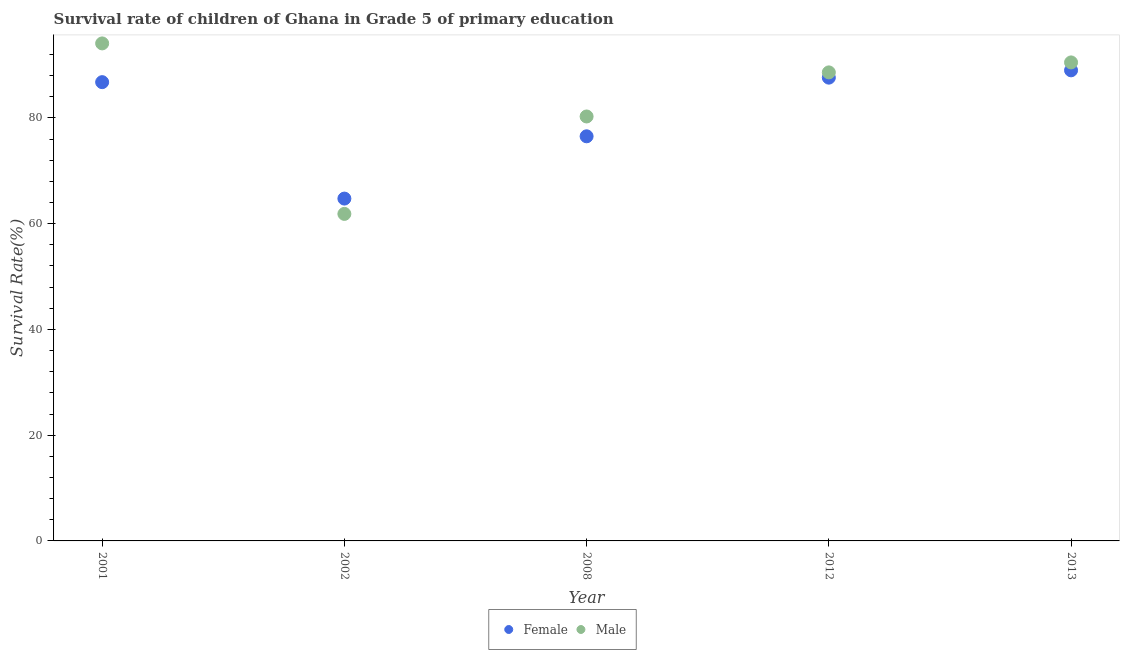How many different coloured dotlines are there?
Your answer should be compact. 2. Is the number of dotlines equal to the number of legend labels?
Provide a succinct answer. Yes. What is the survival rate of male students in primary education in 2002?
Provide a succinct answer. 61.85. Across all years, what is the maximum survival rate of male students in primary education?
Your response must be concise. 94.09. Across all years, what is the minimum survival rate of male students in primary education?
Offer a very short reply. 61.85. In which year was the survival rate of male students in primary education maximum?
Provide a succinct answer. 2001. In which year was the survival rate of female students in primary education minimum?
Ensure brevity in your answer.  2002. What is the total survival rate of male students in primary education in the graph?
Your answer should be very brief. 415.32. What is the difference between the survival rate of male students in primary education in 2012 and that in 2013?
Ensure brevity in your answer.  -1.88. What is the difference between the survival rate of male students in primary education in 2002 and the survival rate of female students in primary education in 2008?
Provide a succinct answer. -14.67. What is the average survival rate of female students in primary education per year?
Ensure brevity in your answer.  80.93. In the year 2002, what is the difference between the survival rate of female students in primary education and survival rate of male students in primary education?
Keep it short and to the point. 2.9. What is the ratio of the survival rate of female students in primary education in 2002 to that in 2013?
Offer a terse response. 0.73. What is the difference between the highest and the second highest survival rate of male students in primary education?
Make the answer very short. 3.6. What is the difference between the highest and the lowest survival rate of male students in primary education?
Offer a very short reply. 32.24. In how many years, is the survival rate of male students in primary education greater than the average survival rate of male students in primary education taken over all years?
Your answer should be very brief. 3. How many dotlines are there?
Give a very brief answer. 2. What is the difference between two consecutive major ticks on the Y-axis?
Offer a very short reply. 20. Does the graph contain any zero values?
Keep it short and to the point. No. Does the graph contain grids?
Give a very brief answer. No. How many legend labels are there?
Make the answer very short. 2. What is the title of the graph?
Provide a succinct answer. Survival rate of children of Ghana in Grade 5 of primary education. Does "From World Bank" appear as one of the legend labels in the graph?
Offer a terse response. No. What is the label or title of the X-axis?
Provide a short and direct response. Year. What is the label or title of the Y-axis?
Keep it short and to the point. Survival Rate(%). What is the Survival Rate(%) of Female in 2001?
Make the answer very short. 86.76. What is the Survival Rate(%) in Male in 2001?
Your answer should be very brief. 94.09. What is the Survival Rate(%) of Female in 2002?
Offer a very short reply. 64.74. What is the Survival Rate(%) of Male in 2002?
Ensure brevity in your answer.  61.85. What is the Survival Rate(%) of Female in 2008?
Ensure brevity in your answer.  76.52. What is the Survival Rate(%) of Male in 2008?
Offer a very short reply. 80.27. What is the Survival Rate(%) in Female in 2012?
Give a very brief answer. 87.61. What is the Survival Rate(%) in Male in 2012?
Ensure brevity in your answer.  88.61. What is the Survival Rate(%) of Female in 2013?
Make the answer very short. 89. What is the Survival Rate(%) in Male in 2013?
Ensure brevity in your answer.  90.49. Across all years, what is the maximum Survival Rate(%) of Female?
Give a very brief answer. 89. Across all years, what is the maximum Survival Rate(%) in Male?
Provide a short and direct response. 94.09. Across all years, what is the minimum Survival Rate(%) of Female?
Ensure brevity in your answer.  64.74. Across all years, what is the minimum Survival Rate(%) of Male?
Your answer should be very brief. 61.85. What is the total Survival Rate(%) of Female in the graph?
Give a very brief answer. 404.64. What is the total Survival Rate(%) in Male in the graph?
Your answer should be very brief. 415.32. What is the difference between the Survival Rate(%) in Female in 2001 and that in 2002?
Offer a terse response. 22.02. What is the difference between the Survival Rate(%) in Male in 2001 and that in 2002?
Your answer should be compact. 32.24. What is the difference between the Survival Rate(%) of Female in 2001 and that in 2008?
Your answer should be very brief. 10.24. What is the difference between the Survival Rate(%) in Male in 2001 and that in 2008?
Provide a short and direct response. 13.82. What is the difference between the Survival Rate(%) in Female in 2001 and that in 2012?
Your answer should be very brief. -0.85. What is the difference between the Survival Rate(%) in Male in 2001 and that in 2012?
Your answer should be compact. 5.48. What is the difference between the Survival Rate(%) of Female in 2001 and that in 2013?
Your answer should be very brief. -2.23. What is the difference between the Survival Rate(%) of Male in 2001 and that in 2013?
Your response must be concise. 3.6. What is the difference between the Survival Rate(%) of Female in 2002 and that in 2008?
Provide a succinct answer. -11.78. What is the difference between the Survival Rate(%) of Male in 2002 and that in 2008?
Give a very brief answer. -18.42. What is the difference between the Survival Rate(%) of Female in 2002 and that in 2012?
Give a very brief answer. -22.87. What is the difference between the Survival Rate(%) in Male in 2002 and that in 2012?
Offer a very short reply. -26.76. What is the difference between the Survival Rate(%) of Female in 2002 and that in 2013?
Your answer should be compact. -24.25. What is the difference between the Survival Rate(%) of Male in 2002 and that in 2013?
Provide a succinct answer. -28.65. What is the difference between the Survival Rate(%) of Female in 2008 and that in 2012?
Offer a terse response. -11.09. What is the difference between the Survival Rate(%) in Male in 2008 and that in 2012?
Provide a short and direct response. -8.34. What is the difference between the Survival Rate(%) of Female in 2008 and that in 2013?
Provide a succinct answer. -12.48. What is the difference between the Survival Rate(%) of Male in 2008 and that in 2013?
Provide a short and direct response. -10.22. What is the difference between the Survival Rate(%) in Female in 2012 and that in 2013?
Ensure brevity in your answer.  -1.38. What is the difference between the Survival Rate(%) of Male in 2012 and that in 2013?
Make the answer very short. -1.88. What is the difference between the Survival Rate(%) in Female in 2001 and the Survival Rate(%) in Male in 2002?
Your answer should be compact. 24.92. What is the difference between the Survival Rate(%) in Female in 2001 and the Survival Rate(%) in Male in 2008?
Offer a very short reply. 6.49. What is the difference between the Survival Rate(%) in Female in 2001 and the Survival Rate(%) in Male in 2012?
Your answer should be compact. -1.85. What is the difference between the Survival Rate(%) of Female in 2001 and the Survival Rate(%) of Male in 2013?
Provide a short and direct response. -3.73. What is the difference between the Survival Rate(%) in Female in 2002 and the Survival Rate(%) in Male in 2008?
Your answer should be compact. -15.53. What is the difference between the Survival Rate(%) in Female in 2002 and the Survival Rate(%) in Male in 2012?
Your response must be concise. -23.87. What is the difference between the Survival Rate(%) in Female in 2002 and the Survival Rate(%) in Male in 2013?
Offer a terse response. -25.75. What is the difference between the Survival Rate(%) in Female in 2008 and the Survival Rate(%) in Male in 2012?
Give a very brief answer. -12.09. What is the difference between the Survival Rate(%) of Female in 2008 and the Survival Rate(%) of Male in 2013?
Make the answer very short. -13.97. What is the difference between the Survival Rate(%) of Female in 2012 and the Survival Rate(%) of Male in 2013?
Make the answer very short. -2.88. What is the average Survival Rate(%) in Female per year?
Your response must be concise. 80.93. What is the average Survival Rate(%) in Male per year?
Keep it short and to the point. 83.06. In the year 2001, what is the difference between the Survival Rate(%) of Female and Survival Rate(%) of Male?
Your response must be concise. -7.33. In the year 2002, what is the difference between the Survival Rate(%) in Female and Survival Rate(%) in Male?
Give a very brief answer. 2.9. In the year 2008, what is the difference between the Survival Rate(%) in Female and Survival Rate(%) in Male?
Make the answer very short. -3.75. In the year 2012, what is the difference between the Survival Rate(%) of Female and Survival Rate(%) of Male?
Provide a short and direct response. -1. In the year 2013, what is the difference between the Survival Rate(%) in Female and Survival Rate(%) in Male?
Your response must be concise. -1.5. What is the ratio of the Survival Rate(%) in Female in 2001 to that in 2002?
Ensure brevity in your answer.  1.34. What is the ratio of the Survival Rate(%) in Male in 2001 to that in 2002?
Your response must be concise. 1.52. What is the ratio of the Survival Rate(%) in Female in 2001 to that in 2008?
Your answer should be compact. 1.13. What is the ratio of the Survival Rate(%) of Male in 2001 to that in 2008?
Your answer should be compact. 1.17. What is the ratio of the Survival Rate(%) of Female in 2001 to that in 2012?
Provide a short and direct response. 0.99. What is the ratio of the Survival Rate(%) of Male in 2001 to that in 2012?
Provide a succinct answer. 1.06. What is the ratio of the Survival Rate(%) of Female in 2001 to that in 2013?
Make the answer very short. 0.97. What is the ratio of the Survival Rate(%) of Male in 2001 to that in 2013?
Provide a succinct answer. 1.04. What is the ratio of the Survival Rate(%) in Female in 2002 to that in 2008?
Your answer should be very brief. 0.85. What is the ratio of the Survival Rate(%) of Male in 2002 to that in 2008?
Your answer should be very brief. 0.77. What is the ratio of the Survival Rate(%) of Female in 2002 to that in 2012?
Ensure brevity in your answer.  0.74. What is the ratio of the Survival Rate(%) of Male in 2002 to that in 2012?
Your answer should be very brief. 0.7. What is the ratio of the Survival Rate(%) in Female in 2002 to that in 2013?
Keep it short and to the point. 0.73. What is the ratio of the Survival Rate(%) in Male in 2002 to that in 2013?
Your answer should be very brief. 0.68. What is the ratio of the Survival Rate(%) of Female in 2008 to that in 2012?
Make the answer very short. 0.87. What is the ratio of the Survival Rate(%) of Male in 2008 to that in 2012?
Offer a very short reply. 0.91. What is the ratio of the Survival Rate(%) of Female in 2008 to that in 2013?
Keep it short and to the point. 0.86. What is the ratio of the Survival Rate(%) of Male in 2008 to that in 2013?
Your answer should be very brief. 0.89. What is the ratio of the Survival Rate(%) in Female in 2012 to that in 2013?
Your answer should be very brief. 0.98. What is the ratio of the Survival Rate(%) of Male in 2012 to that in 2013?
Offer a terse response. 0.98. What is the difference between the highest and the second highest Survival Rate(%) in Female?
Give a very brief answer. 1.38. What is the difference between the highest and the second highest Survival Rate(%) of Male?
Your answer should be very brief. 3.6. What is the difference between the highest and the lowest Survival Rate(%) of Female?
Your response must be concise. 24.25. What is the difference between the highest and the lowest Survival Rate(%) in Male?
Offer a terse response. 32.24. 